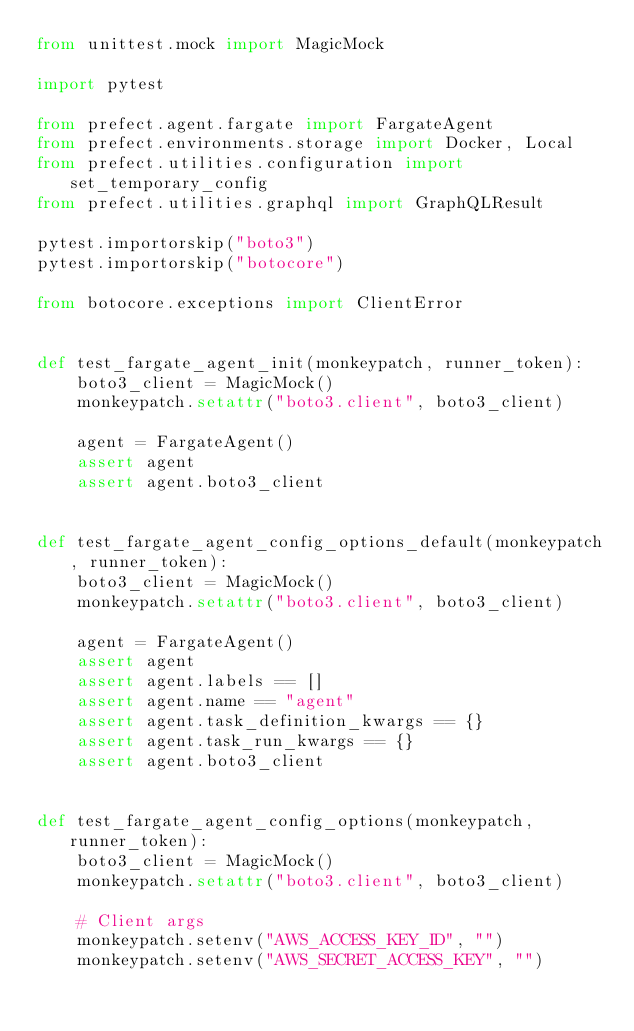<code> <loc_0><loc_0><loc_500><loc_500><_Python_>from unittest.mock import MagicMock

import pytest

from prefect.agent.fargate import FargateAgent
from prefect.environments.storage import Docker, Local
from prefect.utilities.configuration import set_temporary_config
from prefect.utilities.graphql import GraphQLResult

pytest.importorskip("boto3")
pytest.importorskip("botocore")

from botocore.exceptions import ClientError


def test_fargate_agent_init(monkeypatch, runner_token):
    boto3_client = MagicMock()
    monkeypatch.setattr("boto3.client", boto3_client)

    agent = FargateAgent()
    assert agent
    assert agent.boto3_client


def test_fargate_agent_config_options_default(monkeypatch, runner_token):
    boto3_client = MagicMock()
    monkeypatch.setattr("boto3.client", boto3_client)

    agent = FargateAgent()
    assert agent
    assert agent.labels == []
    assert agent.name == "agent"
    assert agent.task_definition_kwargs == {}
    assert agent.task_run_kwargs == {}
    assert agent.boto3_client


def test_fargate_agent_config_options(monkeypatch, runner_token):
    boto3_client = MagicMock()
    monkeypatch.setattr("boto3.client", boto3_client)

    # Client args
    monkeypatch.setenv("AWS_ACCESS_KEY_ID", "")
    monkeypatch.setenv("AWS_SECRET_ACCESS_KEY", "")</code> 